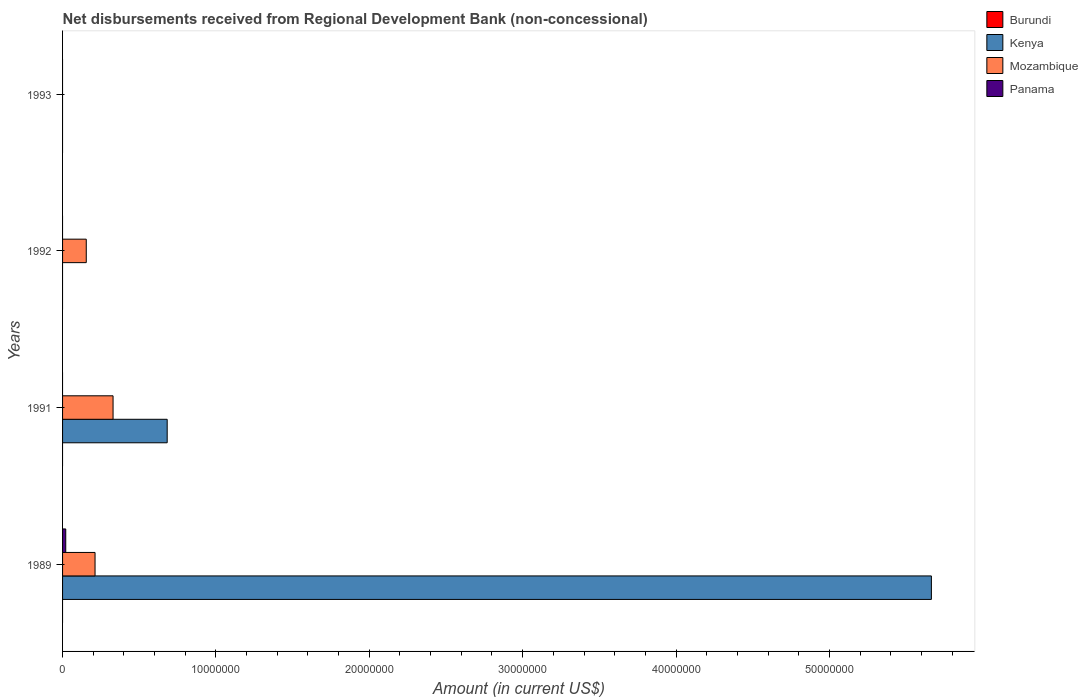How many bars are there on the 2nd tick from the bottom?
Offer a very short reply. 2. What is the label of the 1st group of bars from the top?
Keep it short and to the point. 1993. What is the amount of disbursements received from Regional Development Bank in Kenya in 1992?
Keep it short and to the point. 0. Across all years, what is the maximum amount of disbursements received from Regional Development Bank in Mozambique?
Offer a very short reply. 3.29e+06. What is the total amount of disbursements received from Regional Development Bank in Panama in the graph?
Your answer should be compact. 2.08e+05. What is the difference between the amount of disbursements received from Regional Development Bank in Mozambique in 1989 and that in 1991?
Give a very brief answer. -1.18e+06. What is the difference between the amount of disbursements received from Regional Development Bank in Kenya in 1992 and the amount of disbursements received from Regional Development Bank in Panama in 1989?
Your answer should be compact. -2.08e+05. What is the average amount of disbursements received from Regional Development Bank in Kenya per year?
Your answer should be very brief. 1.59e+07. What is the ratio of the amount of disbursements received from Regional Development Bank in Mozambique in 1989 to that in 1991?
Your answer should be compact. 0.64. What is the difference between the highest and the second highest amount of disbursements received from Regional Development Bank in Mozambique?
Offer a very short reply. 1.18e+06. What is the difference between the highest and the lowest amount of disbursements received from Regional Development Bank in Mozambique?
Keep it short and to the point. 3.29e+06. In how many years, is the amount of disbursements received from Regional Development Bank in Kenya greater than the average amount of disbursements received from Regional Development Bank in Kenya taken over all years?
Ensure brevity in your answer.  1. Is it the case that in every year, the sum of the amount of disbursements received from Regional Development Bank in Mozambique and amount of disbursements received from Regional Development Bank in Burundi is greater than the sum of amount of disbursements received from Regional Development Bank in Panama and amount of disbursements received from Regional Development Bank in Kenya?
Provide a succinct answer. No. Are all the bars in the graph horizontal?
Your answer should be very brief. Yes. What is the difference between two consecutive major ticks on the X-axis?
Ensure brevity in your answer.  1.00e+07. Are the values on the major ticks of X-axis written in scientific E-notation?
Provide a short and direct response. No. Where does the legend appear in the graph?
Your answer should be compact. Top right. How many legend labels are there?
Provide a short and direct response. 4. How are the legend labels stacked?
Offer a terse response. Vertical. What is the title of the graph?
Your answer should be compact. Net disbursements received from Regional Development Bank (non-concessional). What is the Amount (in current US$) in Burundi in 1989?
Your answer should be very brief. 0. What is the Amount (in current US$) of Kenya in 1989?
Provide a short and direct response. 5.67e+07. What is the Amount (in current US$) of Mozambique in 1989?
Your answer should be very brief. 2.12e+06. What is the Amount (in current US$) of Panama in 1989?
Keep it short and to the point. 2.08e+05. What is the Amount (in current US$) in Kenya in 1991?
Provide a succinct answer. 6.82e+06. What is the Amount (in current US$) of Mozambique in 1991?
Provide a short and direct response. 3.29e+06. What is the Amount (in current US$) in Panama in 1991?
Provide a short and direct response. 0. What is the Amount (in current US$) of Burundi in 1992?
Provide a short and direct response. 0. What is the Amount (in current US$) of Kenya in 1992?
Offer a terse response. 0. What is the Amount (in current US$) in Mozambique in 1992?
Give a very brief answer. 1.54e+06. What is the Amount (in current US$) in Burundi in 1993?
Provide a short and direct response. 0. What is the Amount (in current US$) of Kenya in 1993?
Provide a succinct answer. 0. What is the Amount (in current US$) in Mozambique in 1993?
Ensure brevity in your answer.  0. Across all years, what is the maximum Amount (in current US$) of Kenya?
Provide a succinct answer. 5.67e+07. Across all years, what is the maximum Amount (in current US$) of Mozambique?
Your answer should be very brief. 3.29e+06. Across all years, what is the maximum Amount (in current US$) of Panama?
Ensure brevity in your answer.  2.08e+05. Across all years, what is the minimum Amount (in current US$) in Mozambique?
Provide a succinct answer. 0. What is the total Amount (in current US$) of Burundi in the graph?
Make the answer very short. 0. What is the total Amount (in current US$) of Kenya in the graph?
Provide a succinct answer. 6.35e+07. What is the total Amount (in current US$) of Mozambique in the graph?
Make the answer very short. 6.96e+06. What is the total Amount (in current US$) in Panama in the graph?
Provide a succinct answer. 2.08e+05. What is the difference between the Amount (in current US$) of Kenya in 1989 and that in 1991?
Make the answer very short. 4.98e+07. What is the difference between the Amount (in current US$) of Mozambique in 1989 and that in 1991?
Offer a very short reply. -1.18e+06. What is the difference between the Amount (in current US$) in Mozambique in 1989 and that in 1992?
Your response must be concise. 5.73e+05. What is the difference between the Amount (in current US$) in Mozambique in 1991 and that in 1992?
Your answer should be compact. 1.75e+06. What is the difference between the Amount (in current US$) of Kenya in 1989 and the Amount (in current US$) of Mozambique in 1991?
Offer a terse response. 5.34e+07. What is the difference between the Amount (in current US$) in Kenya in 1989 and the Amount (in current US$) in Mozambique in 1992?
Offer a terse response. 5.51e+07. What is the difference between the Amount (in current US$) in Kenya in 1991 and the Amount (in current US$) in Mozambique in 1992?
Give a very brief answer. 5.28e+06. What is the average Amount (in current US$) of Burundi per year?
Provide a succinct answer. 0. What is the average Amount (in current US$) of Kenya per year?
Offer a very short reply. 1.59e+07. What is the average Amount (in current US$) in Mozambique per year?
Your response must be concise. 1.74e+06. What is the average Amount (in current US$) of Panama per year?
Offer a terse response. 5.20e+04. In the year 1989, what is the difference between the Amount (in current US$) of Kenya and Amount (in current US$) of Mozambique?
Offer a terse response. 5.45e+07. In the year 1989, what is the difference between the Amount (in current US$) in Kenya and Amount (in current US$) in Panama?
Make the answer very short. 5.64e+07. In the year 1989, what is the difference between the Amount (in current US$) in Mozambique and Amount (in current US$) in Panama?
Give a very brief answer. 1.91e+06. In the year 1991, what is the difference between the Amount (in current US$) of Kenya and Amount (in current US$) of Mozambique?
Keep it short and to the point. 3.53e+06. What is the ratio of the Amount (in current US$) in Kenya in 1989 to that in 1991?
Provide a succinct answer. 8.3. What is the ratio of the Amount (in current US$) in Mozambique in 1989 to that in 1991?
Provide a succinct answer. 0.64. What is the ratio of the Amount (in current US$) of Mozambique in 1989 to that in 1992?
Give a very brief answer. 1.37. What is the ratio of the Amount (in current US$) in Mozambique in 1991 to that in 1992?
Keep it short and to the point. 2.13. What is the difference between the highest and the second highest Amount (in current US$) of Mozambique?
Ensure brevity in your answer.  1.18e+06. What is the difference between the highest and the lowest Amount (in current US$) of Kenya?
Keep it short and to the point. 5.67e+07. What is the difference between the highest and the lowest Amount (in current US$) in Mozambique?
Keep it short and to the point. 3.29e+06. What is the difference between the highest and the lowest Amount (in current US$) of Panama?
Offer a very short reply. 2.08e+05. 